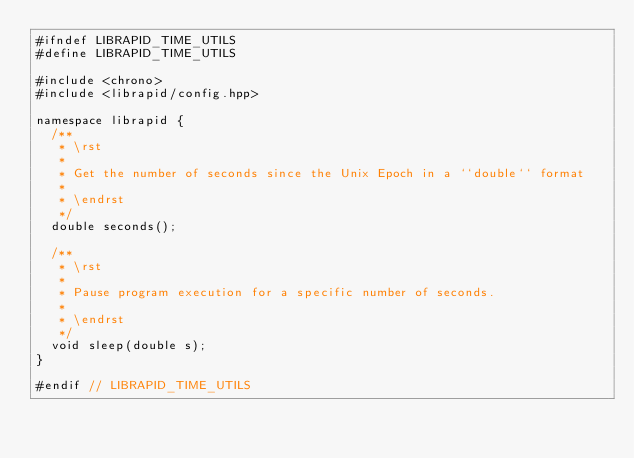<code> <loc_0><loc_0><loc_500><loc_500><_C++_>#ifndef LIBRAPID_TIME_UTILS
#define LIBRAPID_TIME_UTILS

#include <chrono>
#include <librapid/config.hpp>

namespace librapid {
	/**
	 * \rst
	 *
	 * Get the number of seconds since the Unix Epoch in a ``double`` format
	 *
	 * \endrst
	 */
	double seconds();

	/**
	 * \rst
	 *
	 * Pause program execution for a specific number of seconds.
	 *
	 * \endrst
	 */
	void sleep(double s);
}

#endif // LIBRAPID_TIME_UTILS</code> 